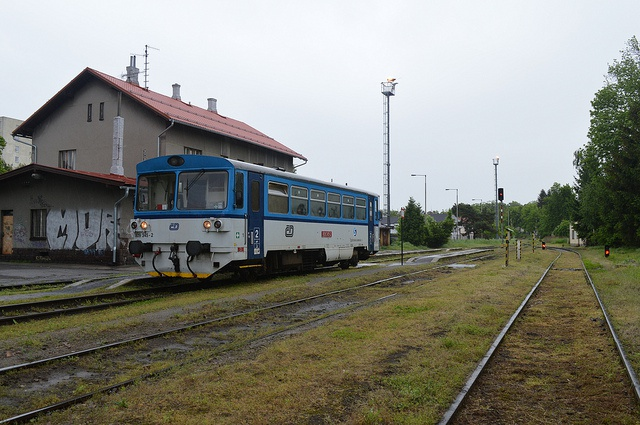Describe the objects in this image and their specific colors. I can see train in white, black, gray, and navy tones, traffic light in white, black, maroon, and red tones, traffic light in white, black, maroon, lightgray, and gray tones, people in white, black, purple, and gray tones, and traffic light in white, black, maroon, gray, and tan tones in this image. 